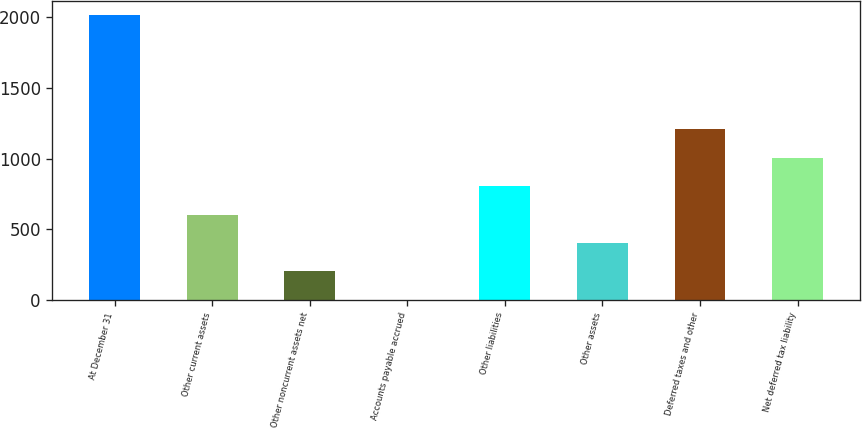Convert chart. <chart><loc_0><loc_0><loc_500><loc_500><bar_chart><fcel>At December 31<fcel>Other current assets<fcel>Other noncurrent assets net<fcel>Accounts payable accrued<fcel>Other liabilities<fcel>Other assets<fcel>Deferred taxes and other<fcel>Net deferred tax liability<nl><fcel>2013<fcel>604.32<fcel>201.84<fcel>0.6<fcel>805.56<fcel>403.08<fcel>1208.04<fcel>1006.8<nl></chart> 